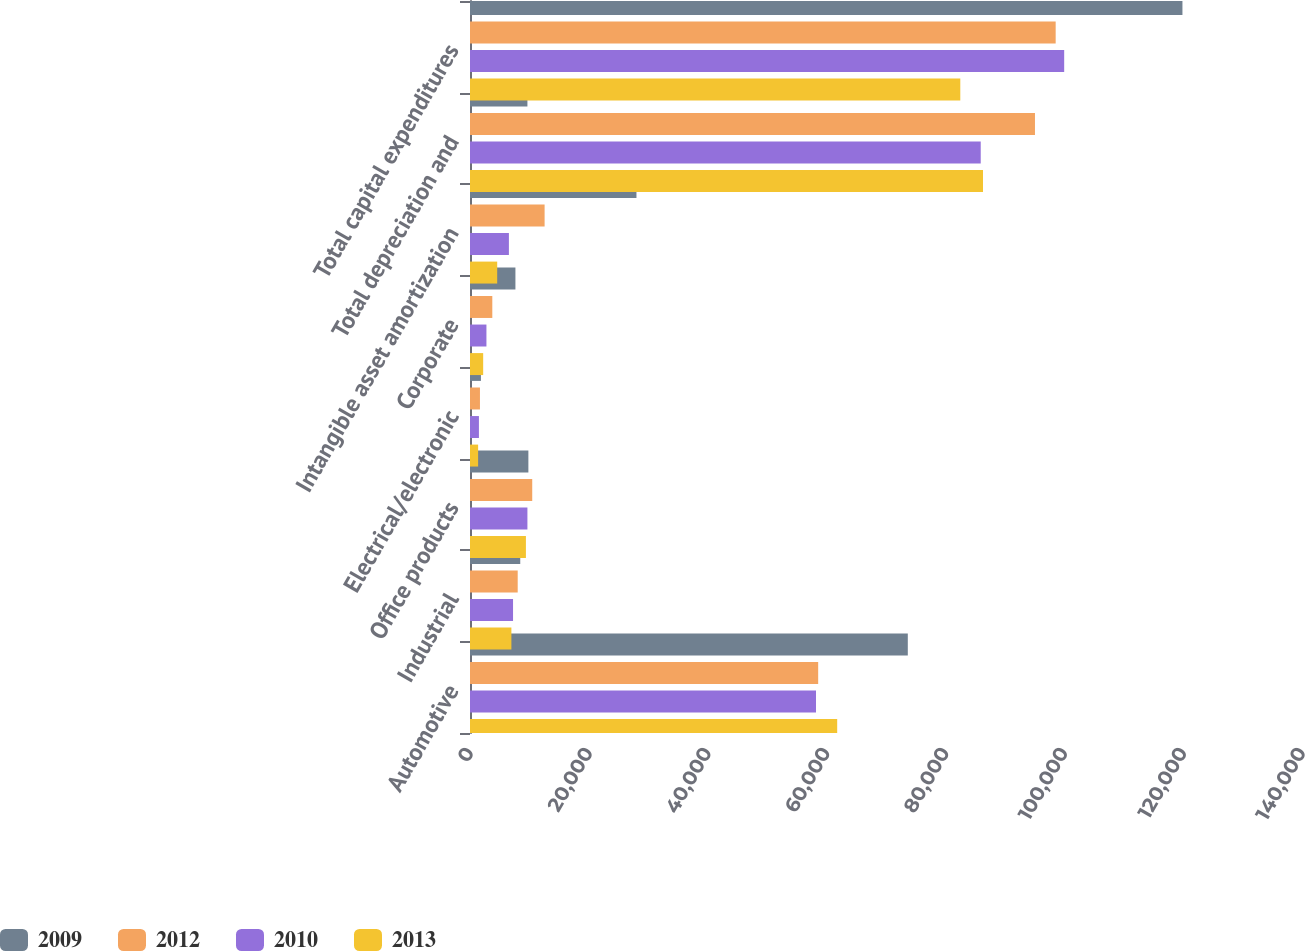Convert chart. <chart><loc_0><loc_0><loc_500><loc_500><stacked_bar_chart><ecel><fcel>Automotive<fcel>Industrial<fcel>Office products<fcel>Electrical/electronic<fcel>Corporate<fcel>Intangible asset amortization<fcel>Total depreciation and<fcel>Total capital expenditures<nl><fcel>2009<fcel>76238<fcel>8751<fcel>10166<fcel>1904<fcel>7911<fcel>28987<fcel>9999<fcel>124063<nl><fcel>2012<fcel>60630<fcel>8307<fcel>10837<fcel>1733<fcel>3885<fcel>12991<fcel>98383<fcel>101987<nl><fcel>2010<fcel>60252<fcel>7495<fcel>9999<fcel>1554<fcel>2862<fcel>6774<fcel>88936<fcel>103469<nl><fcel>2013<fcel>63942<fcel>7208<fcel>9737<fcel>1414<fcel>2294<fcel>4737<fcel>89332<fcel>85379<nl></chart> 